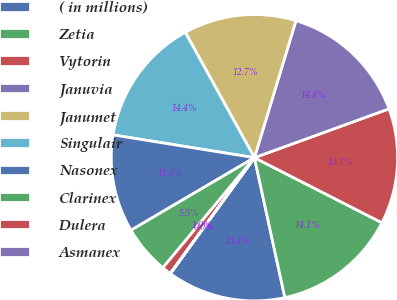Convert chart to OTSL. <chart><loc_0><loc_0><loc_500><loc_500><pie_chart><fcel>( in millions)<fcel>Zetia<fcel>Vytorin<fcel>Januvia<fcel>Janumet<fcel>Singulair<fcel>Nasonex<fcel>Clarinex<fcel>Dulera<fcel>Asmanex<nl><fcel>13.4%<fcel>14.08%<fcel>13.05%<fcel>14.77%<fcel>12.71%<fcel>14.43%<fcel>11.0%<fcel>5.5%<fcel>1.04%<fcel>0.01%<nl></chart> 